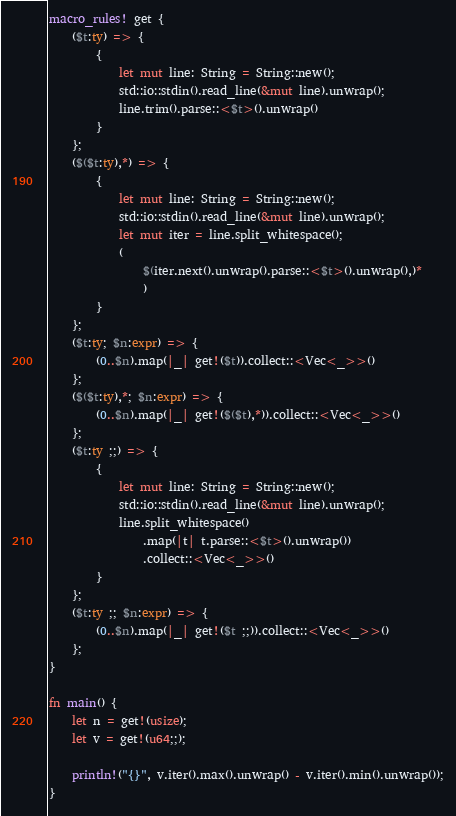Convert code to text. <code><loc_0><loc_0><loc_500><loc_500><_Rust_>macro_rules! get {
    ($t:ty) => {
        {
            let mut line: String = String::new();
            std::io::stdin().read_line(&mut line).unwrap();
            line.trim().parse::<$t>().unwrap()
        }
    };
    ($($t:ty),*) => {
        {
            let mut line: String = String::new();
            std::io::stdin().read_line(&mut line).unwrap();
            let mut iter = line.split_whitespace();
            (
                $(iter.next().unwrap().parse::<$t>().unwrap(),)*
                )
        }
    };
    ($t:ty; $n:expr) => {
        (0..$n).map(|_| get!($t)).collect::<Vec<_>>()
    };
    ($($t:ty),*; $n:expr) => {
        (0..$n).map(|_| get!($($t),*)).collect::<Vec<_>>()
    };
    ($t:ty ;;) => {
        {
            let mut line: String = String::new();
            std::io::stdin().read_line(&mut line).unwrap();
            line.split_whitespace()
                .map(|t| t.parse::<$t>().unwrap())
                .collect::<Vec<_>>()
        }
    };
    ($t:ty ;; $n:expr) => {
        (0..$n).map(|_| get!($t ;;)).collect::<Vec<_>>()
    };
}

fn main() {
    let n = get!(usize);
    let v = get!(u64;;);

    println!("{}", v.iter().max().unwrap() - v.iter().min().unwrap());
}
</code> 